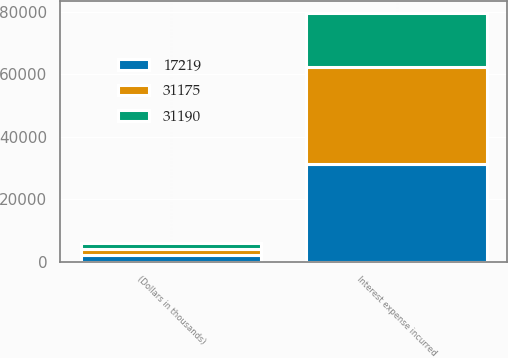Convert chart. <chart><loc_0><loc_0><loc_500><loc_500><stacked_bar_chart><ecel><fcel>(Dollars in thousands)<fcel>Interest expense incurred<nl><fcel>31190<fcel>2010<fcel>17219<nl><fcel>31175<fcel>2009<fcel>31190<nl><fcel>17219<fcel>2008<fcel>31175<nl></chart> 